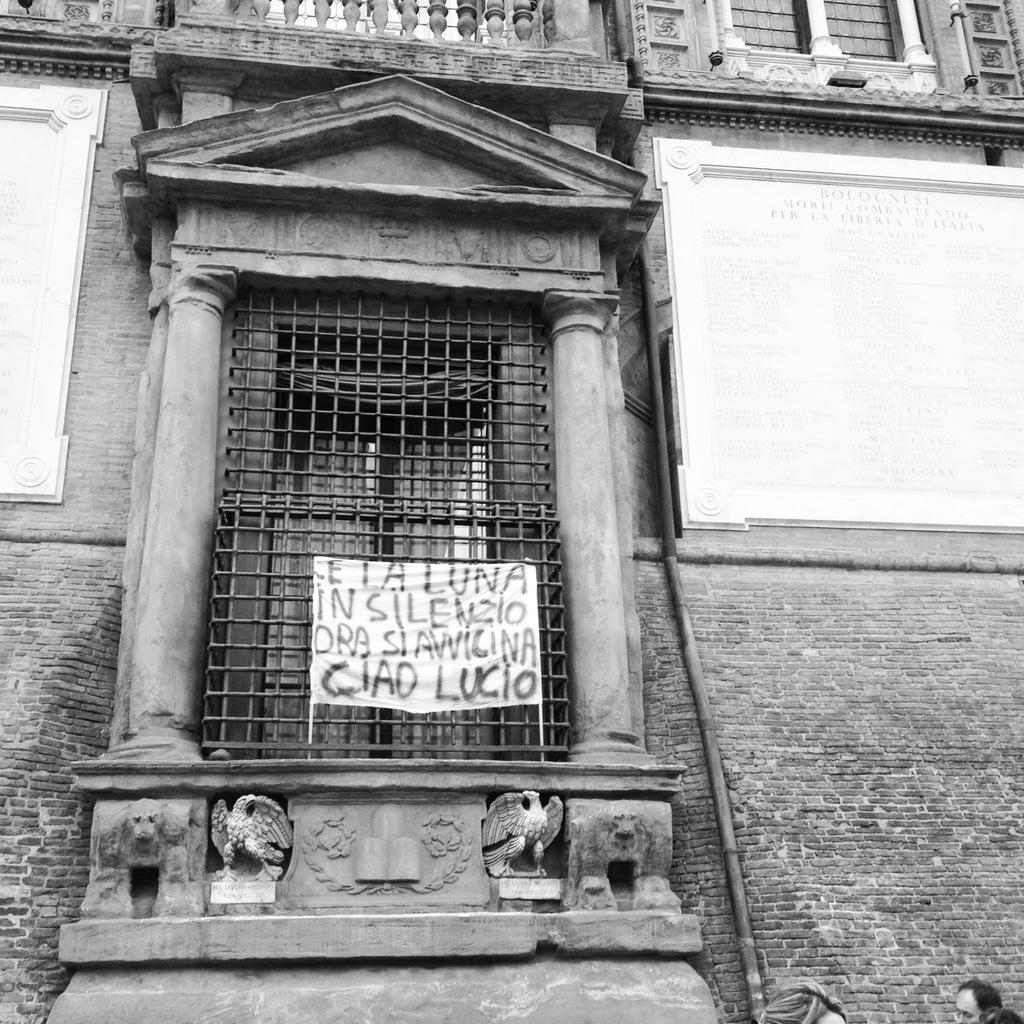In one or two sentences, can you explain what this image depicts? In this picture we can see a building with windows, banner, wall, pipes and some persons. 